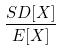Convert formula to latex. <formula><loc_0><loc_0><loc_500><loc_500>\frac { S D [ X ] } { E [ X ] }</formula> 